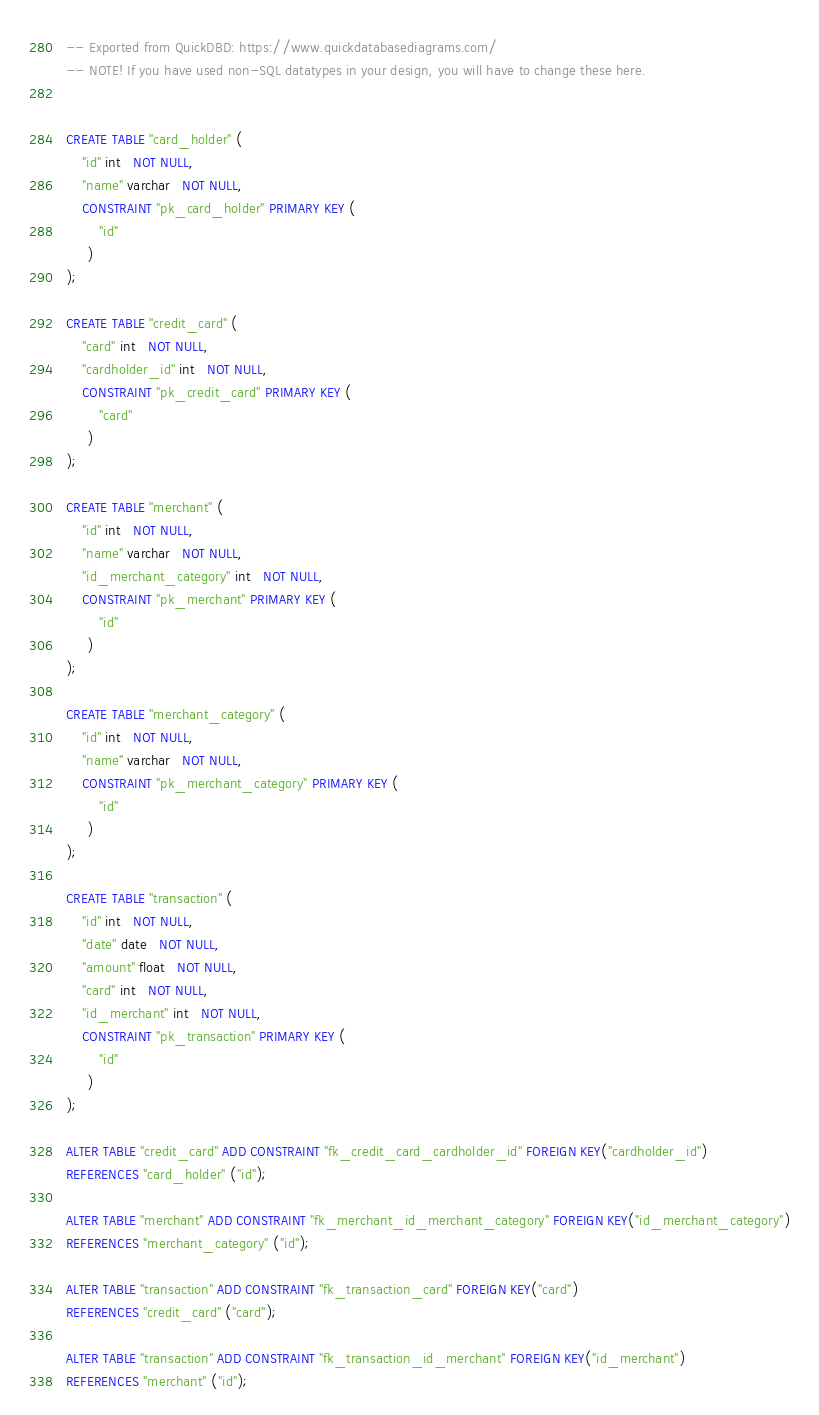Convert code to text. <code><loc_0><loc_0><loc_500><loc_500><_SQL_>-- Exported from QuickDBD: https://www.quickdatabasediagrams.com/
-- NOTE! If you have used non-SQL datatypes in your design, you will have to change these here.


CREATE TABLE "card_holder" (
    "id" int   NOT NULL,
    "name" varchar   NOT NULL,
    CONSTRAINT "pk_card_holder" PRIMARY KEY (
        "id"
     )
);

CREATE TABLE "credit_card" (
    "card" int   NOT NULL,
    "cardholder_id" int   NOT NULL,
    CONSTRAINT "pk_credit_card" PRIMARY KEY (
        "card"
     )
);

CREATE TABLE "merchant" (
    "id" int   NOT NULL,
    "name" varchar   NOT NULL,
    "id_merchant_category" int   NOT NULL,
    CONSTRAINT "pk_merchant" PRIMARY KEY (
        "id"
     )
);

CREATE TABLE "merchant_category" (
    "id" int   NOT NULL,
    "name" varchar   NOT NULL,
    CONSTRAINT "pk_merchant_category" PRIMARY KEY (
        "id"
     )
);

CREATE TABLE "transaction" (
    "id" int   NOT NULL,
    "date" date   NOT NULL,
    "amount" float   NOT NULL,
    "card" int   NOT NULL,
    "id_merchant" int   NOT NULL,
    CONSTRAINT "pk_transaction" PRIMARY KEY (
        "id"
     )
);

ALTER TABLE "credit_card" ADD CONSTRAINT "fk_credit_card_cardholder_id" FOREIGN KEY("cardholder_id")
REFERENCES "card_holder" ("id");

ALTER TABLE "merchant" ADD CONSTRAINT "fk_merchant_id_merchant_category" FOREIGN KEY("id_merchant_category")
REFERENCES "merchant_category" ("id");

ALTER TABLE "transaction" ADD CONSTRAINT "fk_transaction_card" FOREIGN KEY("card")
REFERENCES "credit_card" ("card");

ALTER TABLE "transaction" ADD CONSTRAINT "fk_transaction_id_merchant" FOREIGN KEY("id_merchant")
REFERENCES "merchant" ("id");</code> 